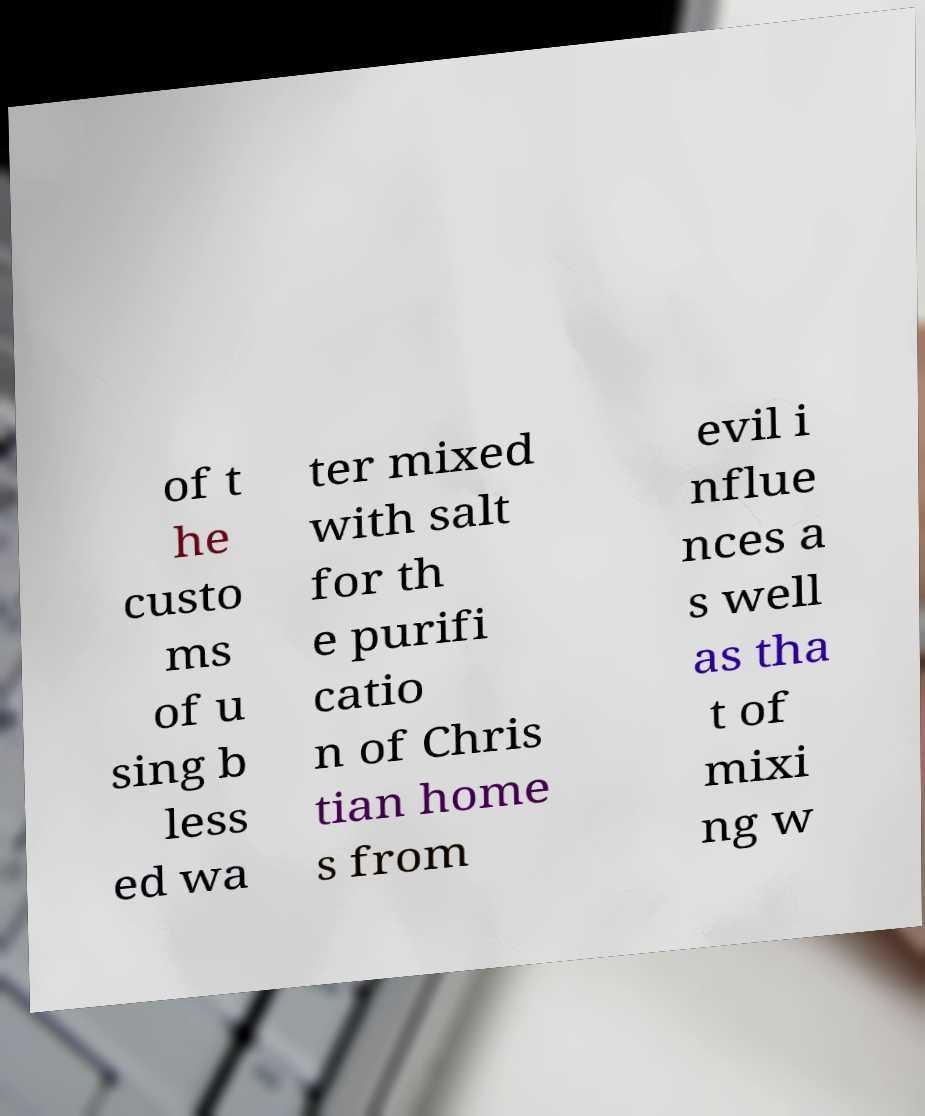Could you extract and type out the text from this image? of t he custo ms of u sing b less ed wa ter mixed with salt for th e purifi catio n of Chris tian home s from evil i nflue nces a s well as tha t of mixi ng w 